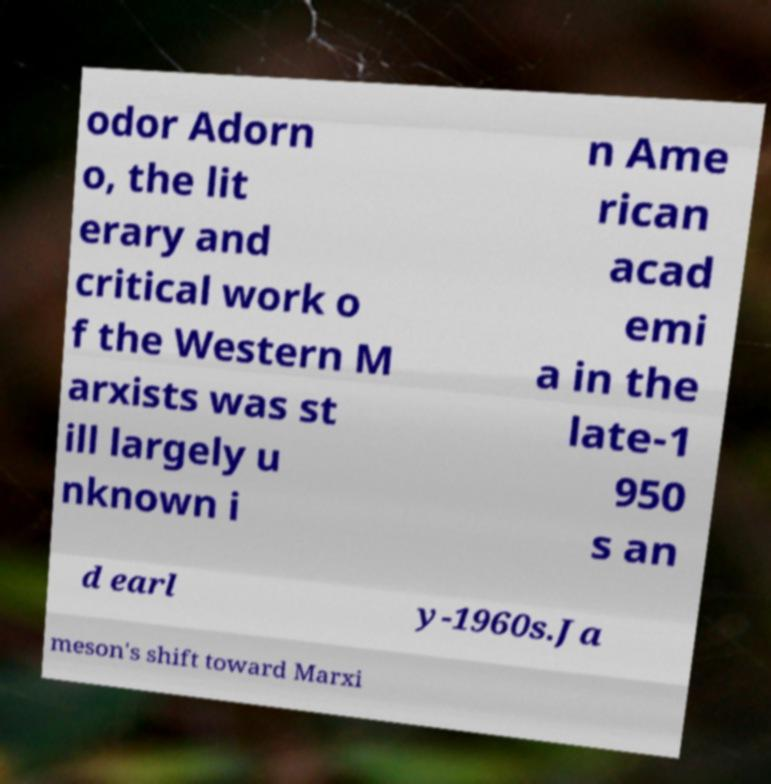Please identify and transcribe the text found in this image. odor Adorn o, the lit erary and critical work o f the Western M arxists was st ill largely u nknown i n Ame rican acad emi a in the late-1 950 s an d earl y-1960s.Ja meson's shift toward Marxi 